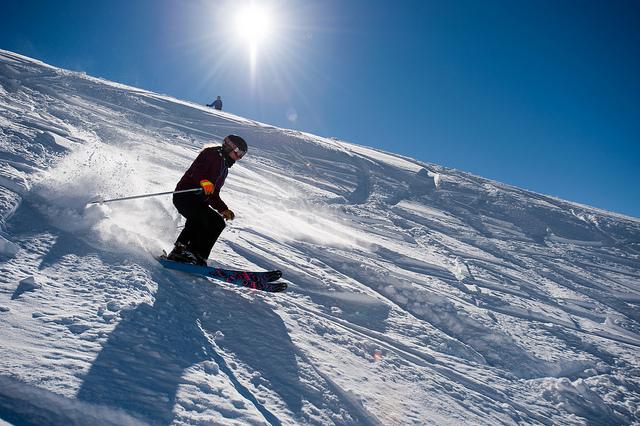Is this a cold place?
Answer briefly. Yes. Are there any clouds in the sky?
Keep it brief. No. What is the grade of this steep hill?
Be succinct. 45 degrees. 